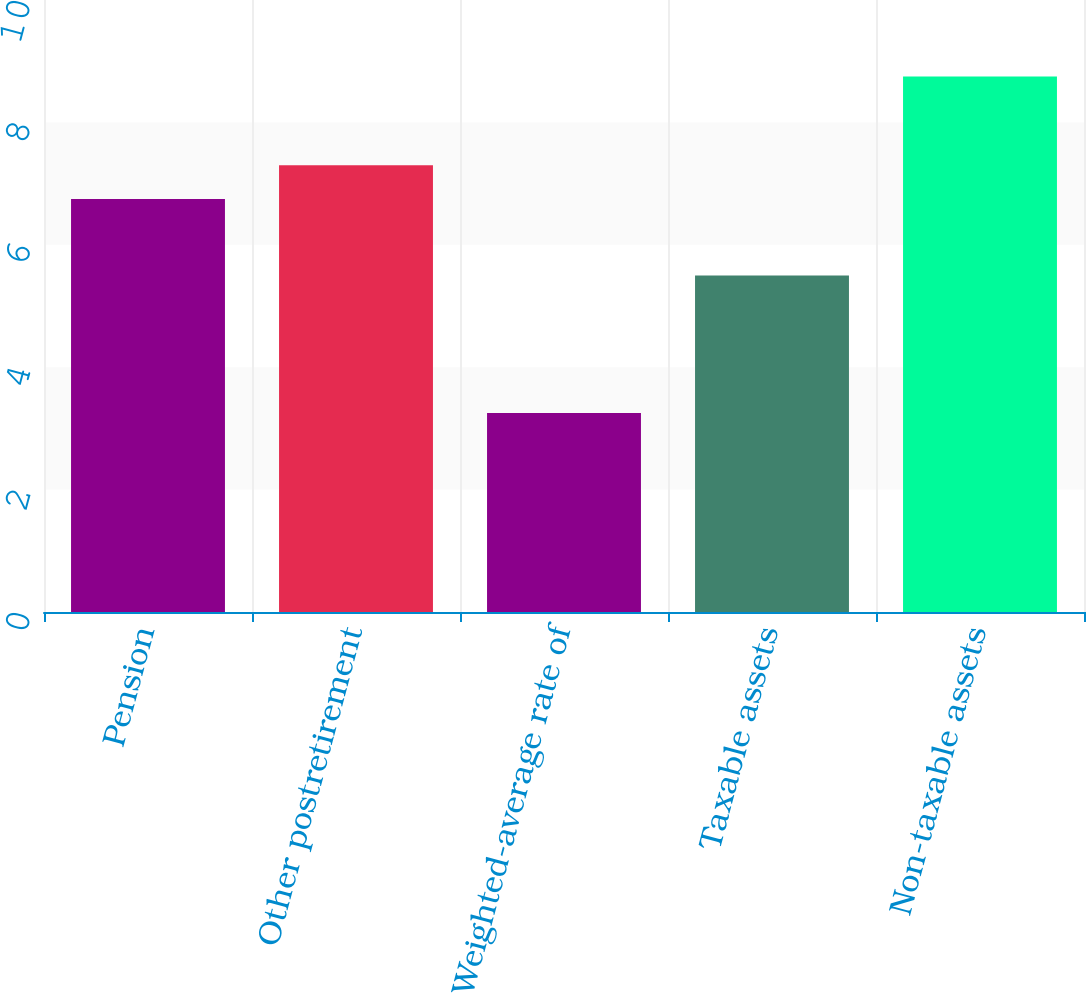Convert chart to OTSL. <chart><loc_0><loc_0><loc_500><loc_500><bar_chart><fcel>Pension<fcel>Other postretirement<fcel>Weighted-average rate of<fcel>Taxable assets<fcel>Non-taxable assets<nl><fcel>6.75<fcel>7.3<fcel>3.25<fcel>5.5<fcel>8.75<nl></chart> 